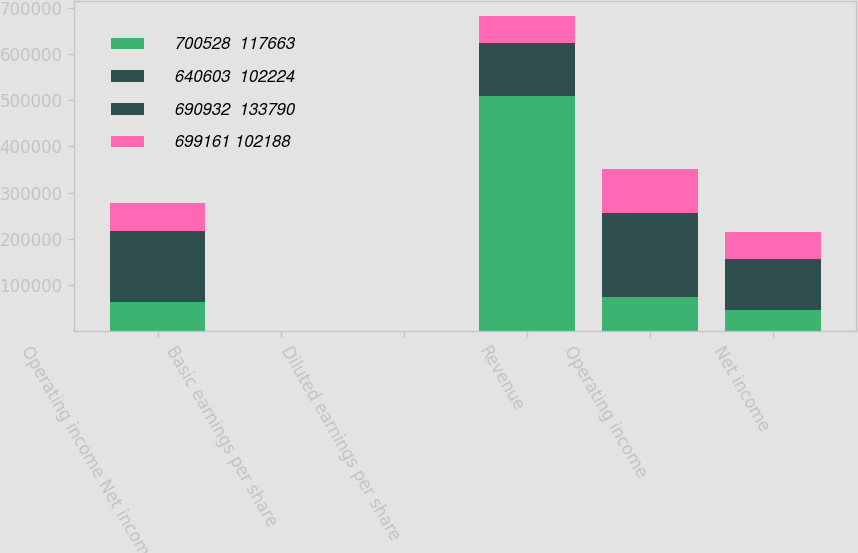Convert chart. <chart><loc_0><loc_0><loc_500><loc_500><stacked_bar_chart><ecel><fcel>Operating income Net income<fcel>Basic earnings per share<fcel>Diluted earnings per share<fcel>Revenue<fcel>Operating income<fcel>Net income<nl><fcel>700528  117663<fcel>62664<fcel>2<fcel>1.97<fcel>509384<fcel>74821<fcel>46382<nl><fcel>640603  102224<fcel>81683<fcel>2.58<fcel>2.56<fcel>57473<fcel>83863<fcel>50657<nl><fcel>690932  133790<fcel>72300<fcel>2.28<fcel>2.27<fcel>57473<fcel>98010<fcel>60433<nl><fcel>699161 102188<fcel>61353<fcel>1.96<fcel>1.95<fcel>57473<fcel>93868<fcel>57473<nl></chart> 